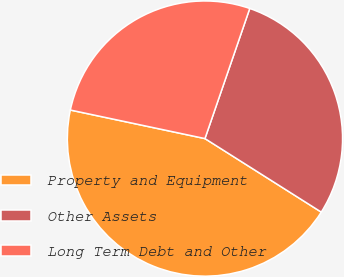<chart> <loc_0><loc_0><loc_500><loc_500><pie_chart><fcel>Property and Equipment<fcel>Other Assets<fcel>Long Term Debt and Other<nl><fcel>44.35%<fcel>28.69%<fcel>26.95%<nl></chart> 